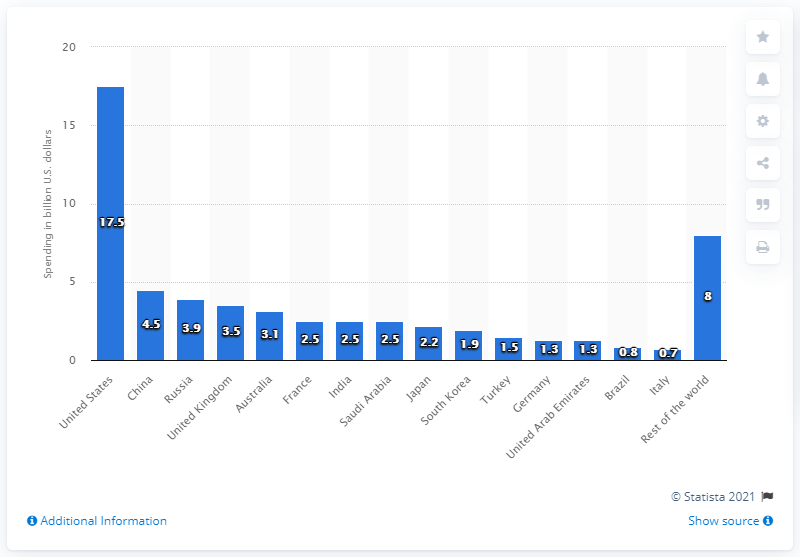Why might the 'Rest of the World' category have relatively low spending? The 'Rest of the World' category shows a relatively low spending of $0.7 billion, which could be due to smaller economies or less emphasis on drone technology in these regions compared to global powers like the U.S., China, and Russia. 